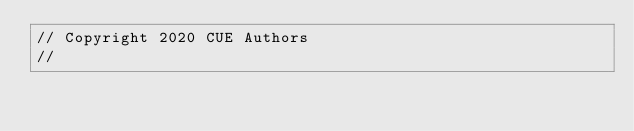<code> <loc_0><loc_0><loc_500><loc_500><_Go_>// Copyright 2020 CUE Authors
//</code> 